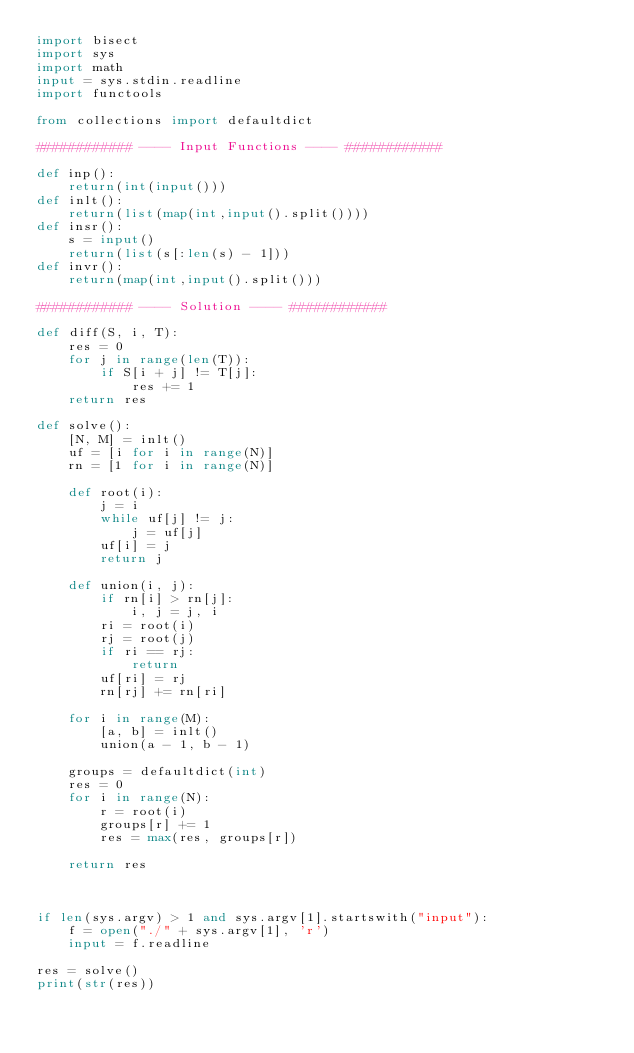Convert code to text. <code><loc_0><loc_0><loc_500><loc_500><_Python_>import bisect
import sys
import math
input = sys.stdin.readline
import functools

from collections import defaultdict

############ ---- Input Functions ---- ############

def inp():
    return(int(input()))
def inlt():
    return(list(map(int,input().split())))
def insr():
    s = input()
    return(list(s[:len(s) - 1]))
def invr():
    return(map(int,input().split()))

############ ---- Solution ---- ############

def diff(S, i, T):
    res = 0
    for j in range(len(T)):
        if S[i + j] != T[j]:
            res += 1
    return res

def solve():
    [N, M] = inlt()
    uf = [i for i in range(N)]
    rn = [1 for i in range(N)]

    def root(i):
        j = i
        while uf[j] != j:
            j = uf[j]
        uf[i] = j
        return j

    def union(i, j):
        if rn[i] > rn[j]:
            i, j = j, i
        ri = root(i)
        rj = root(j)
        if ri == rj:
            return
        uf[ri] = rj
        rn[rj] += rn[ri]

    for i in range(M):
        [a, b] = inlt()
        union(a - 1, b - 1)

    groups = defaultdict(int)
    res = 0
    for i in range(N):
        r = root(i)
        groups[r] += 1
        res = max(res, groups[r])
    
    return res

    

if len(sys.argv) > 1 and sys.argv[1].startswith("input"):
    f = open("./" + sys.argv[1], 'r')
    input = f.readline

res = solve()
print(str(res))
</code> 